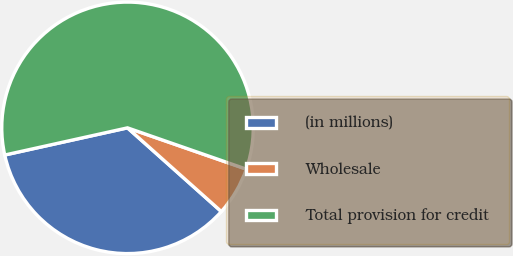<chart> <loc_0><loc_0><loc_500><loc_500><pie_chart><fcel>(in millions)<fcel>Wholesale<fcel>Total provision for credit<nl><fcel>34.94%<fcel>6.27%<fcel>58.79%<nl></chart> 